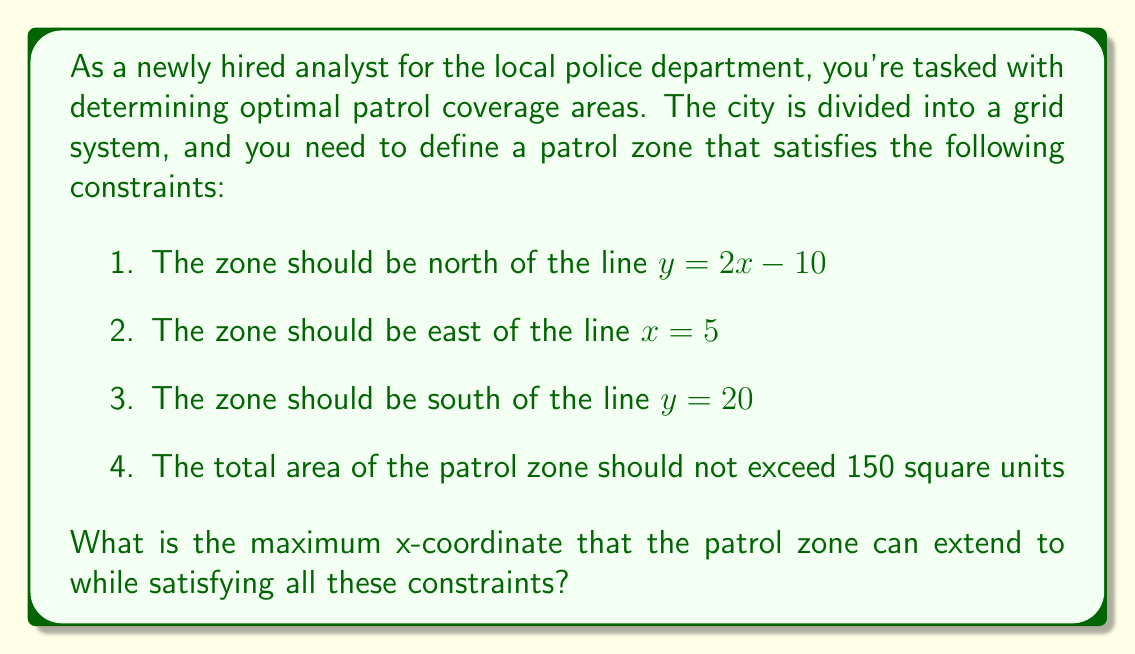Solve this math problem. Let's approach this step-by-step:

1) First, we need to visualize the constraints. We have three linear inequalities:

   $y > 2x - 10$
   $x > 5$
   $y < 20$

2) These inequalities define a triangular region. Let's find the points of intersection:

   - Line 1 and Line 2: $y = 2(5) - 10 = 0$ at $x = 5$
   - Line 1 and Line 3: $20 = 2x - 10$, so $x = 15$ at $y = 20$
   - Line 2 and Line 3: $x = 5$ at $y = 20$

3) The triangle is formed by the points (5,0), (5,20), and (15,20).

4) The area of this triangle is:

   $A = \frac{1}{2} * base * height = \frac{1}{2} * 10 * 20 = 100$ square units

5) Since the maximum area is 150 square units, we can extend this triangle to the right.

6) Let the maximum x-coordinate be $a$. The new triangle will have points (5,0), (5,20), and (a,20).

7) The area of this new triangle should be 150:

   $150 = \frac{1}{2} * (a-5) * 20$

8) Solving for $a$:

   $150 = 10(a-5)$
   $15 = a-5$
   $a = 20$

Therefore, the maximum x-coordinate is 20.
Answer: 20 